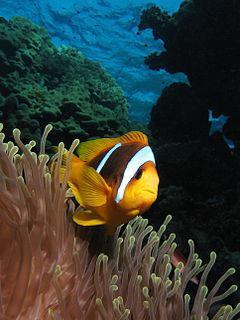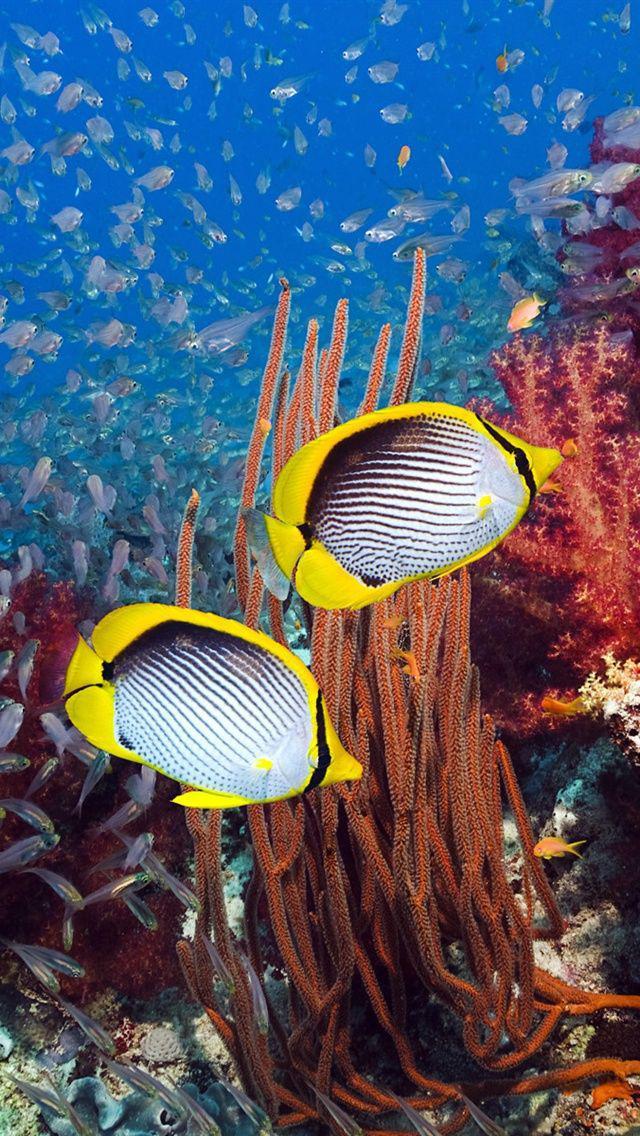The first image is the image on the left, the second image is the image on the right. Given the left and right images, does the statement "There is exactly one clown fish." hold true? Answer yes or no. Yes. The first image is the image on the left, the second image is the image on the right. Assess this claim about the two images: "Each image shows at least two brightly colored striped fish of the same variety swimming in a scene that contains anemone tendrils.". Correct or not? Answer yes or no. No. 